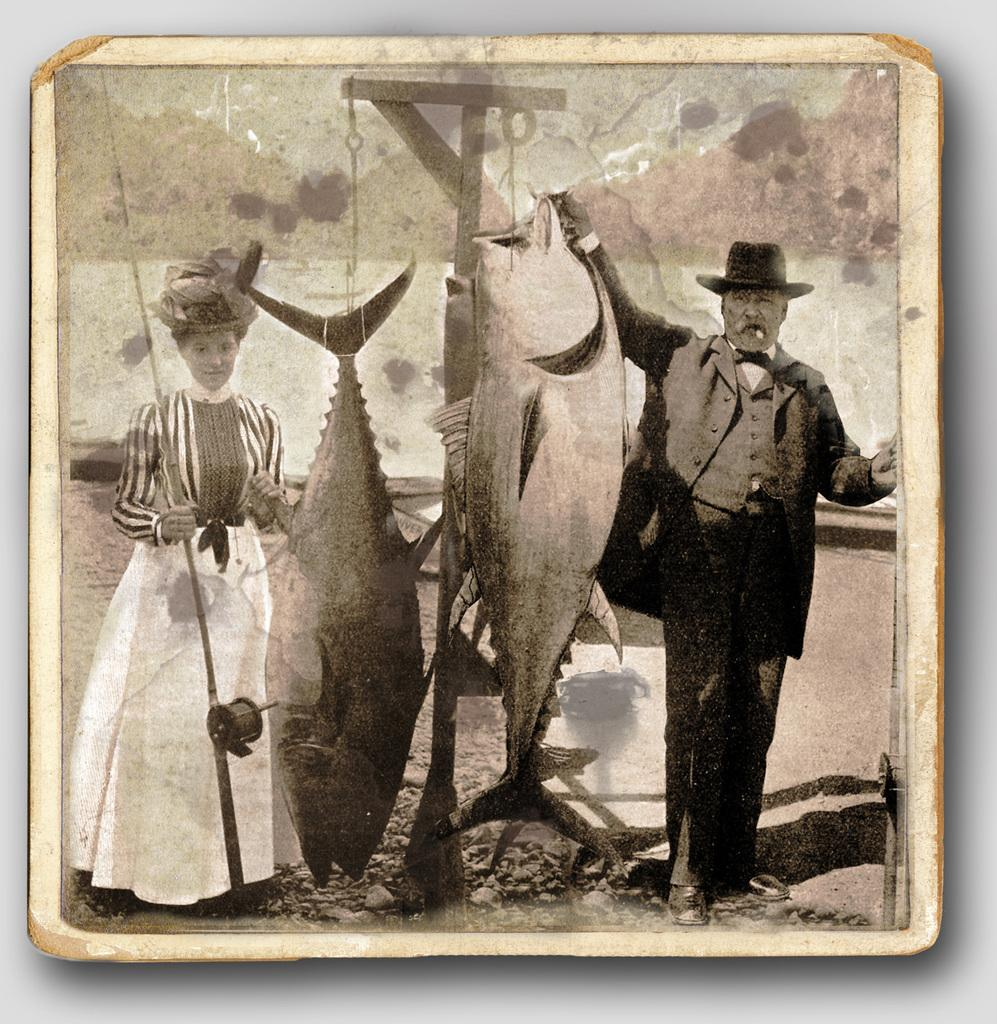What type of photograph is the image? The image is a black and white photograph. Who are the people in the photograph? There are pictures of a man and woman in the photograph. What are the man and woman doing in the photograph? The man and woman are standing on the ground and holding fishes in their hands. What type of waste can be seen in the photograph? There is no waste visible in the photograph; it features a man and woman holding fishes. What type of protest is taking place in the photograph? There is no protest depicted in the photograph; it shows a man and woman holding fishes. 